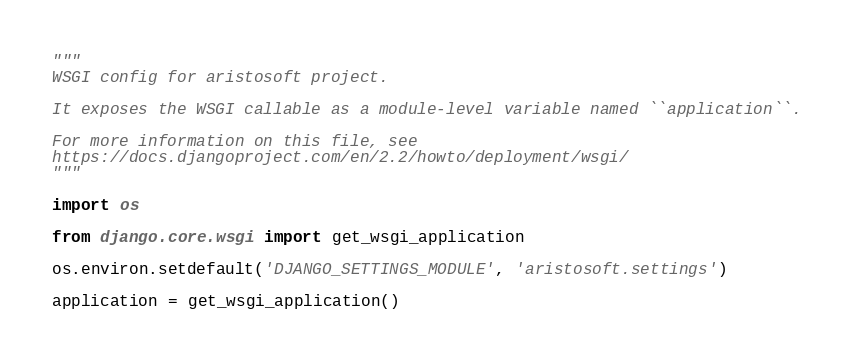Convert code to text. <code><loc_0><loc_0><loc_500><loc_500><_Python_>"""
WSGI config for aristosoft project.

It exposes the WSGI callable as a module-level variable named ``application``.

For more information on this file, see
https://docs.djangoproject.com/en/2.2/howto/deployment/wsgi/
"""

import os

from django.core.wsgi import get_wsgi_application

os.environ.setdefault('DJANGO_SETTINGS_MODULE', 'aristosoft.settings')

application = get_wsgi_application()
</code> 